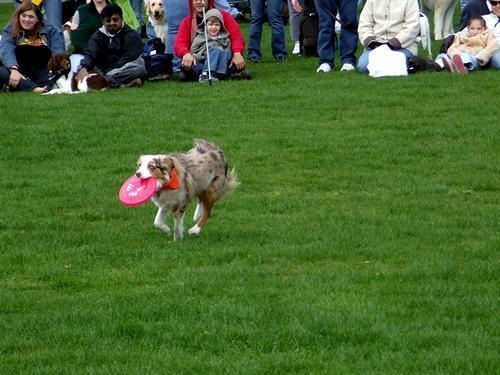How many people are there?
Give a very brief answer. 6. 